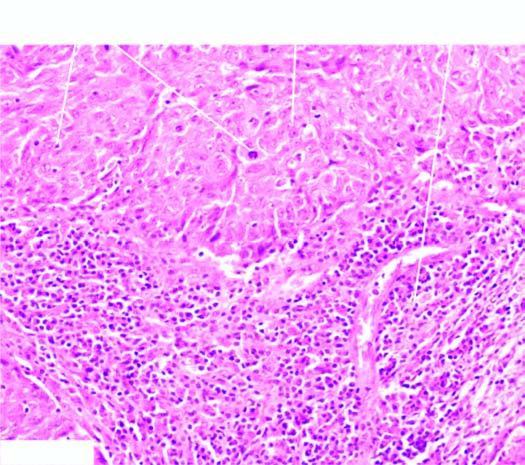how are two characteristic features-large tumour cells forming syncytial arrangement and stroma infiltrated richly?
Answer the question using a single word or phrase. With lymphocytes 